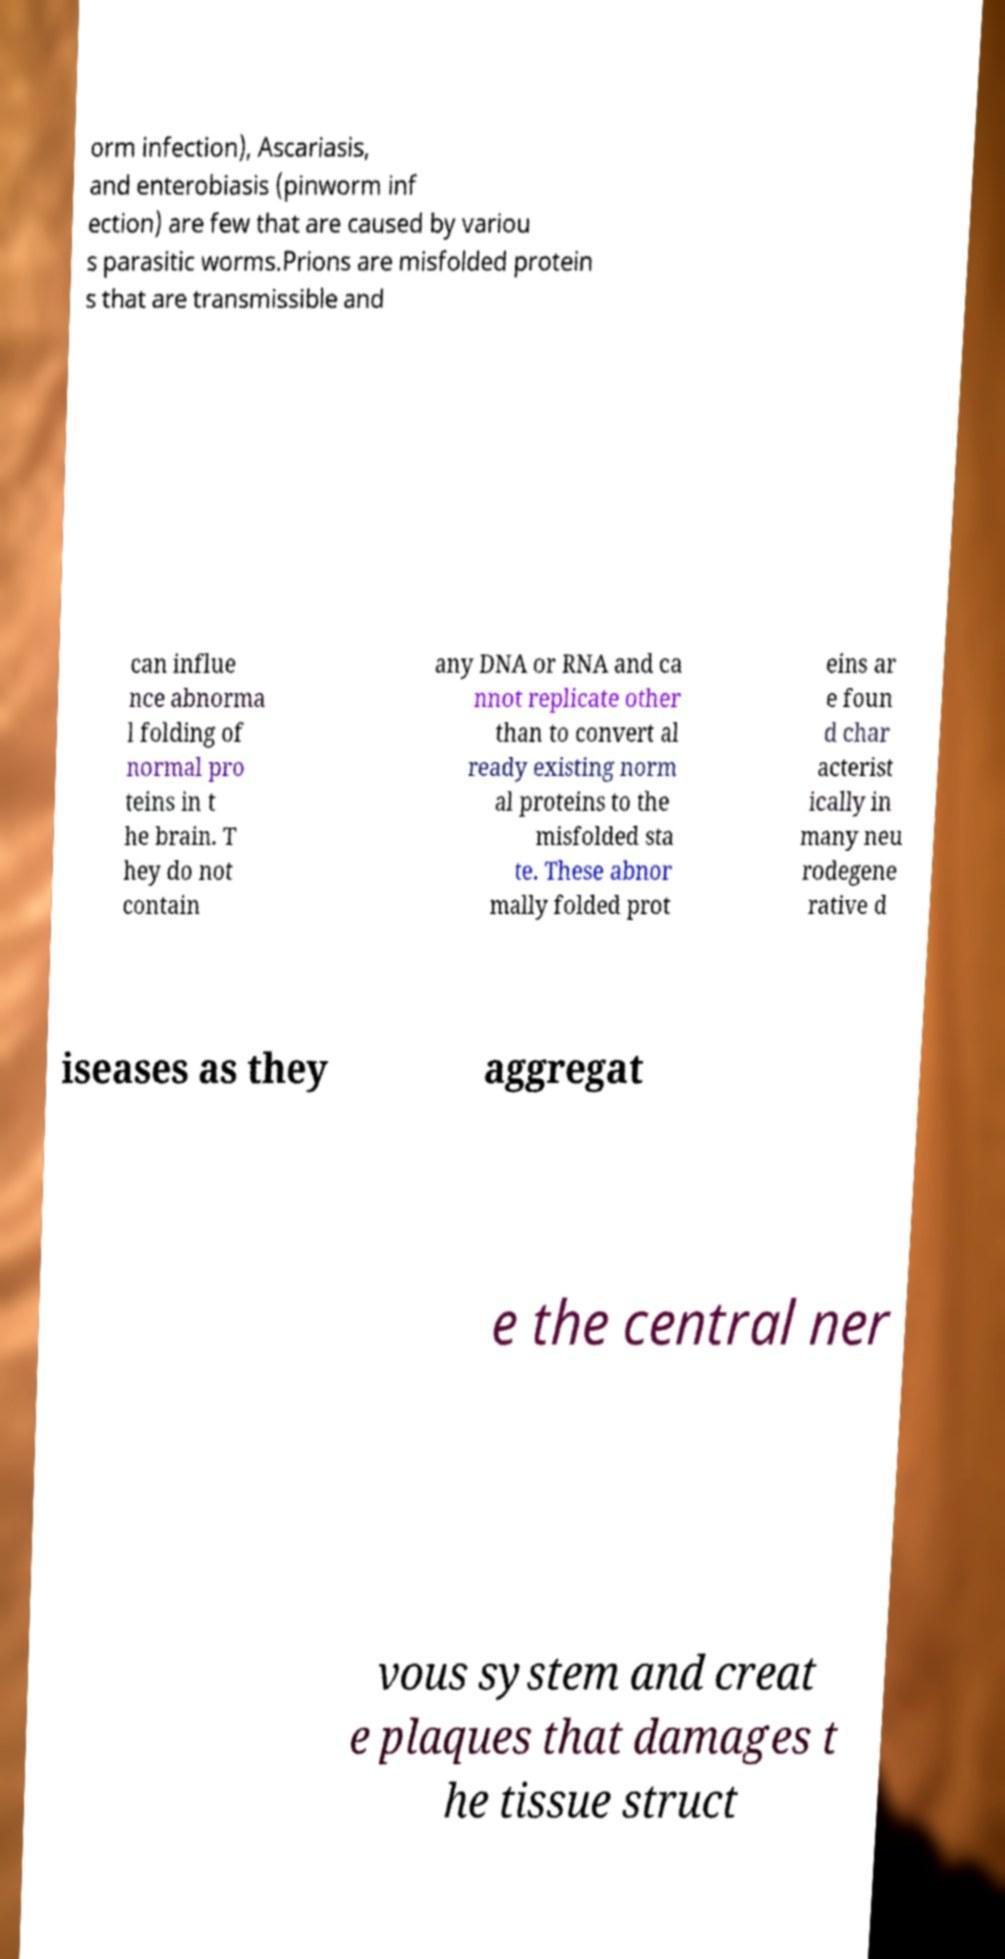Can you read and provide the text displayed in the image?This photo seems to have some interesting text. Can you extract and type it out for me? orm infection), Ascariasis, and enterobiasis (pinworm inf ection) are few that are caused by variou s parasitic worms.Prions are misfolded protein s that are transmissible and can influe nce abnorma l folding of normal pro teins in t he brain. T hey do not contain any DNA or RNA and ca nnot replicate other than to convert al ready existing norm al proteins to the misfolded sta te. These abnor mally folded prot eins ar e foun d char acterist ically in many neu rodegene rative d iseases as they aggregat e the central ner vous system and creat e plaques that damages t he tissue struct 